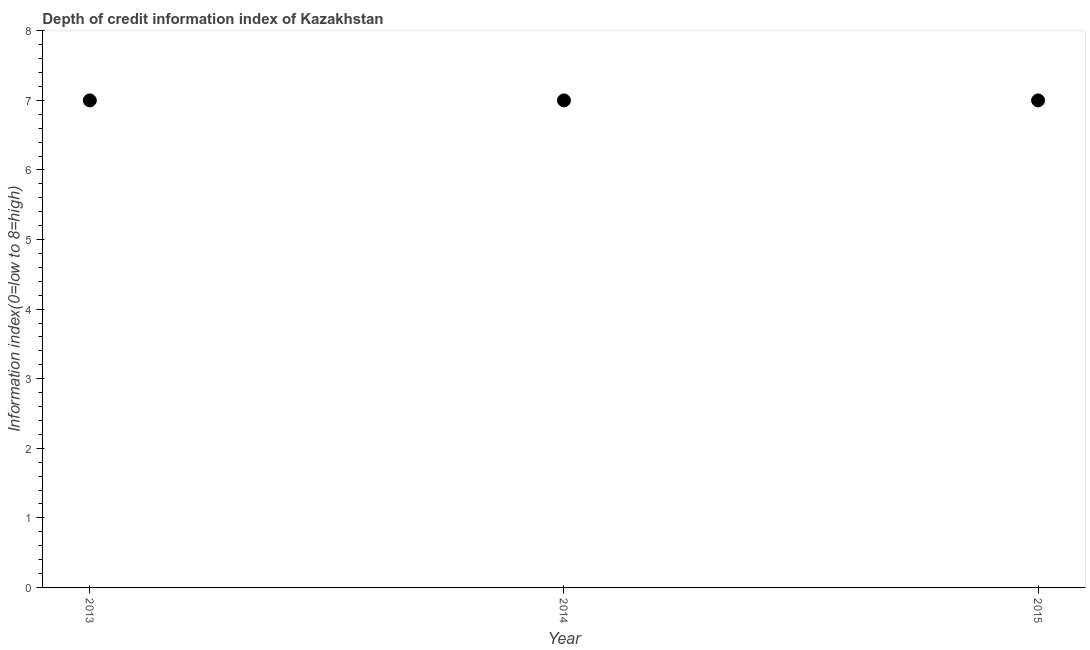What is the depth of credit information index in 2015?
Provide a succinct answer. 7. Across all years, what is the maximum depth of credit information index?
Make the answer very short. 7. Across all years, what is the minimum depth of credit information index?
Provide a succinct answer. 7. In which year was the depth of credit information index maximum?
Your answer should be very brief. 2013. In which year was the depth of credit information index minimum?
Offer a very short reply. 2013. What is the sum of the depth of credit information index?
Ensure brevity in your answer.  21. What is the difference between the depth of credit information index in 2014 and 2015?
Give a very brief answer. 0. What is the average depth of credit information index per year?
Offer a very short reply. 7. In how many years, is the depth of credit information index greater than 7 ?
Provide a short and direct response. 0. Do a majority of the years between 2015 and 2014 (inclusive) have depth of credit information index greater than 7.8 ?
Offer a terse response. No. What is the ratio of the depth of credit information index in 2014 to that in 2015?
Provide a short and direct response. 1. Is the difference between the depth of credit information index in 2014 and 2015 greater than the difference between any two years?
Ensure brevity in your answer.  Yes. Is the sum of the depth of credit information index in 2014 and 2015 greater than the maximum depth of credit information index across all years?
Offer a very short reply. Yes. Does the depth of credit information index monotonically increase over the years?
Offer a very short reply. No. What is the difference between two consecutive major ticks on the Y-axis?
Ensure brevity in your answer.  1. Are the values on the major ticks of Y-axis written in scientific E-notation?
Offer a very short reply. No. Does the graph contain any zero values?
Ensure brevity in your answer.  No. What is the title of the graph?
Keep it short and to the point. Depth of credit information index of Kazakhstan. What is the label or title of the Y-axis?
Your answer should be compact. Information index(0=low to 8=high). What is the Information index(0=low to 8=high) in 2014?
Your answer should be compact. 7. What is the Information index(0=low to 8=high) in 2015?
Give a very brief answer. 7. What is the difference between the Information index(0=low to 8=high) in 2013 and 2015?
Offer a very short reply. 0. What is the difference between the Information index(0=low to 8=high) in 2014 and 2015?
Provide a succinct answer. 0. What is the ratio of the Information index(0=low to 8=high) in 2013 to that in 2015?
Offer a terse response. 1. What is the ratio of the Information index(0=low to 8=high) in 2014 to that in 2015?
Offer a terse response. 1. 